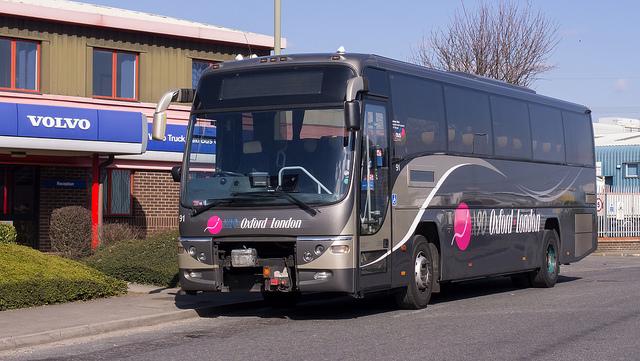Is the bus parked?
Be succinct. Yes. Why is the bus parked?
Short answer required. Waiting. What car company is on the sign?
Write a very short answer. Volvo. 